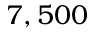<formula> <loc_0><loc_0><loc_500><loc_500>7 , 5 0 0</formula> 